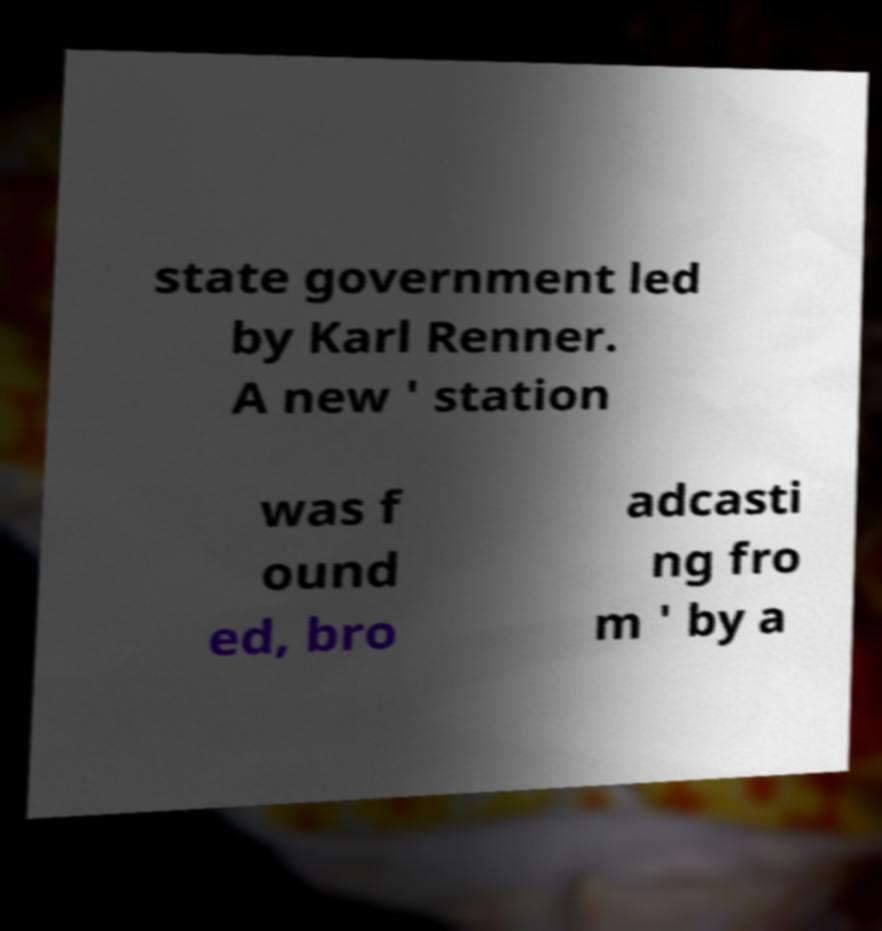Please identify and transcribe the text found in this image. state government led by Karl Renner. A new ' station was f ound ed, bro adcasti ng fro m ' by a 